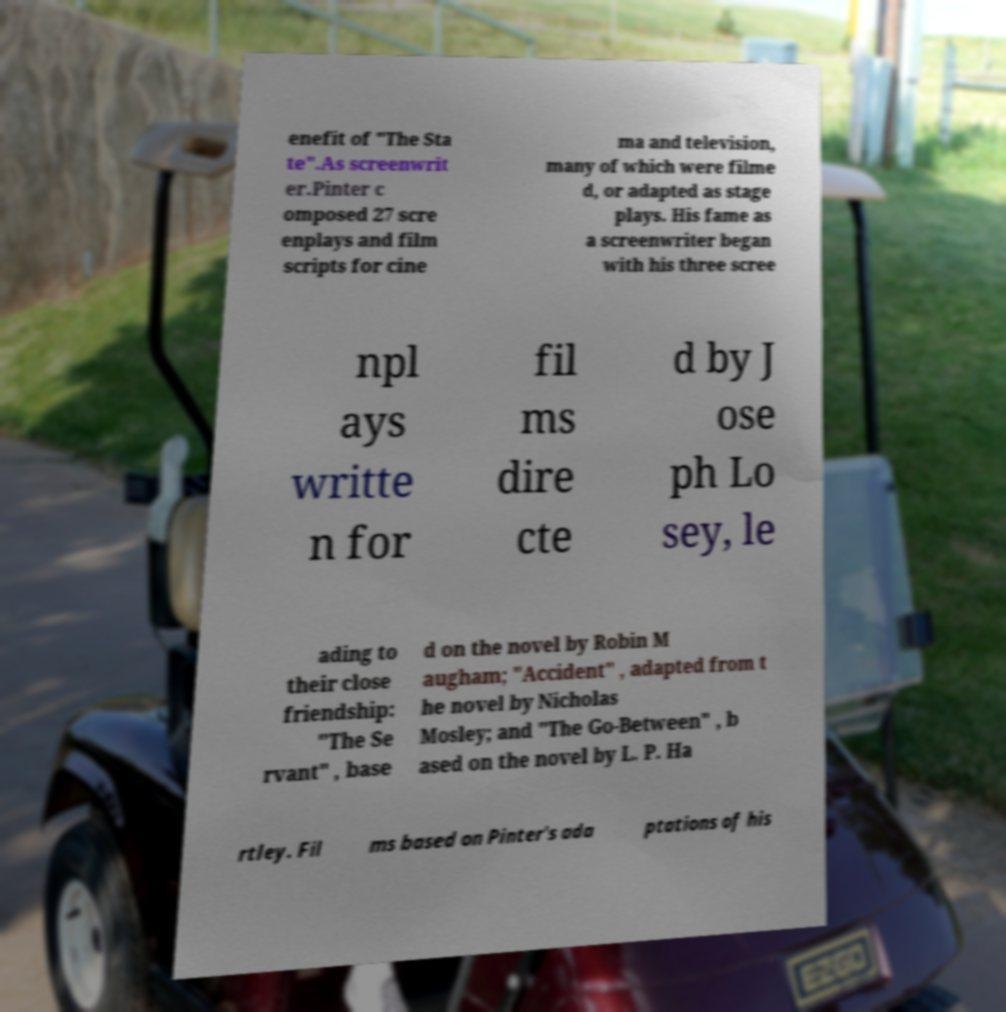There's text embedded in this image that I need extracted. Can you transcribe it verbatim? enefit of "The Sta te".As screenwrit er.Pinter c omposed 27 scre enplays and film scripts for cine ma and television, many of which were filme d, or adapted as stage plays. His fame as a screenwriter began with his three scree npl ays writte n for fil ms dire cte d by J ose ph Lo sey, le ading to their close friendship: "The Se rvant" , base d on the novel by Robin M augham; "Accident" , adapted from t he novel by Nicholas Mosley; and "The Go-Between" , b ased on the novel by L. P. Ha rtley. Fil ms based on Pinter's ada ptations of his 